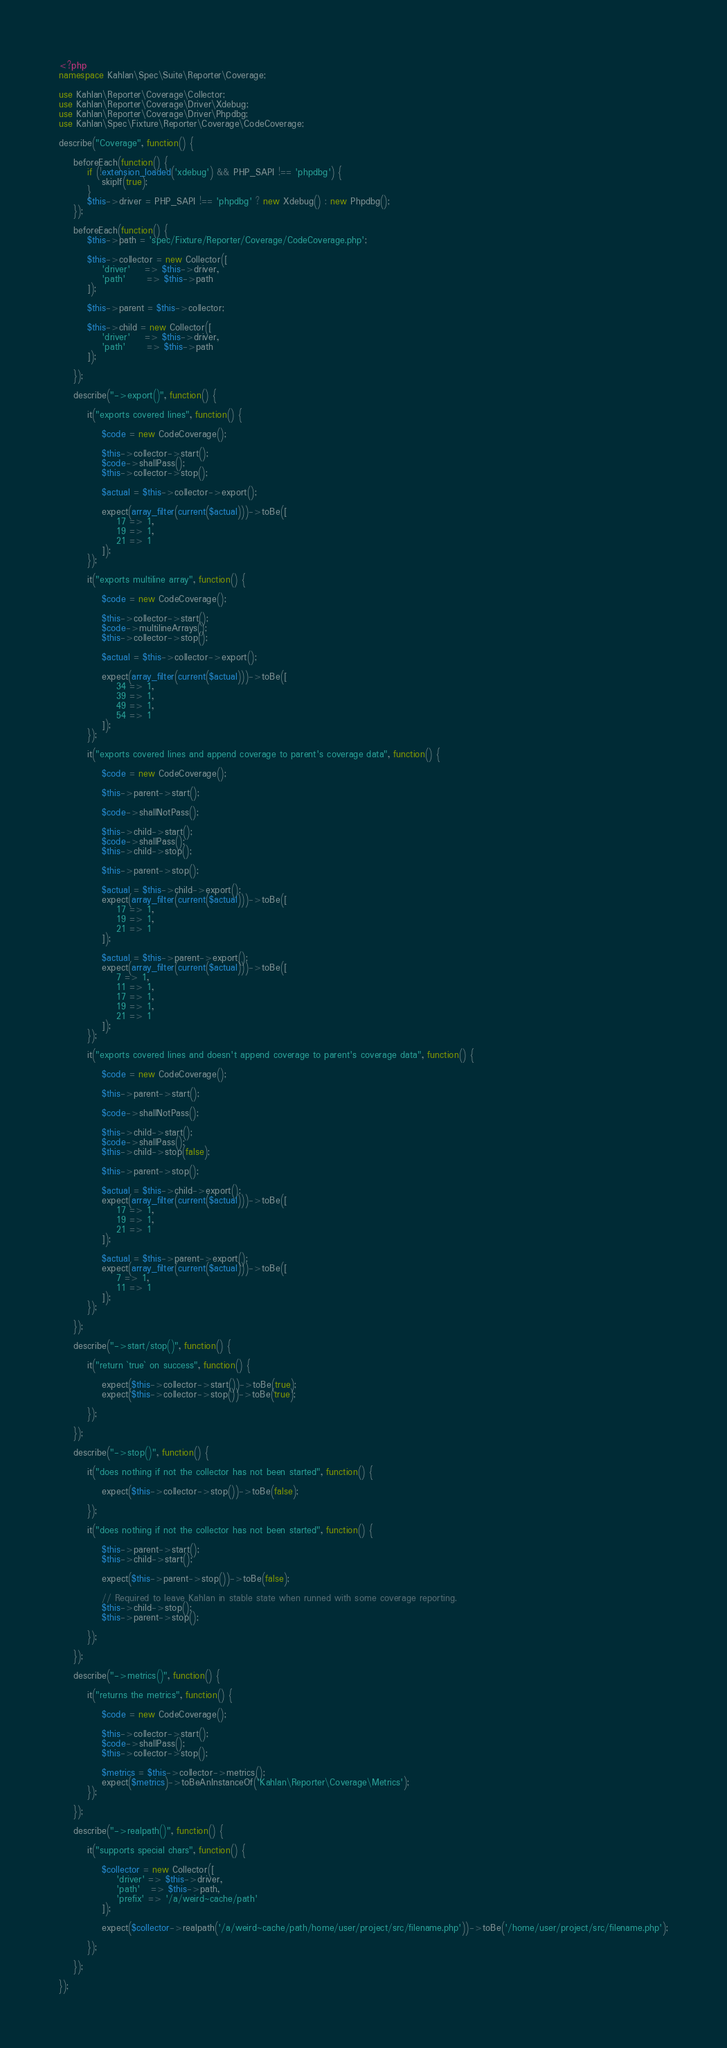Convert code to text. <code><loc_0><loc_0><loc_500><loc_500><_PHP_><?php
namespace Kahlan\Spec\Suite\Reporter\Coverage;

use Kahlan\Reporter\Coverage\Collector;
use Kahlan\Reporter\Coverage\Driver\Xdebug;
use Kahlan\Reporter\Coverage\Driver\Phpdbg;
use Kahlan\Spec\Fixture\Reporter\Coverage\CodeCoverage;

describe("Coverage", function() {

    beforeEach(function() {
        if (!extension_loaded('xdebug') && PHP_SAPI !== 'phpdbg') {
            skipIf(true);
        }
        $this->driver = PHP_SAPI !== 'phpdbg' ? new Xdebug() : new Phpdbg();
    });

    beforeEach(function() {
        $this->path = 'spec/Fixture/Reporter/Coverage/CodeCoverage.php';

        $this->collector = new Collector([
            'driver'    => $this->driver,
            'path'      => $this->path
        ]);

        $this->parent = $this->collector;

        $this->child = new Collector([
            'driver'    => $this->driver,
            'path'      => $this->path
        ]);

    });

    describe("->export()", function() {

        it("exports covered lines", function() {

            $code = new CodeCoverage();

            $this->collector->start();
            $code->shallPass();
            $this->collector->stop();

            $actual = $this->collector->export();

            expect(array_filter(current($actual)))->toBe([
                17 => 1,
                19 => 1,
                21 => 1
            ]);
        });

        it("exports multiline array", function() {

            $code = new CodeCoverage();

            $this->collector->start();
            $code->multilineArrays();
            $this->collector->stop();

            $actual = $this->collector->export();

            expect(array_filter(current($actual)))->toBe([
                34 => 1,
                39 => 1,
                49 => 1,
                54 => 1
            ]);
        });

        it("exports covered lines and append coverage to parent's coverage data", function() {

            $code = new CodeCoverage();

            $this->parent->start();

            $code->shallNotPass();

            $this->child->start();
            $code->shallPass();
            $this->child->stop();

            $this->parent->stop();

            $actual = $this->child->export();
            expect(array_filter(current($actual)))->toBe([
                17 => 1,
                19 => 1,
                21 => 1
            ]);

            $actual = $this->parent->export();
            expect(array_filter(current($actual)))->toBe([
                7 => 1,
                11 => 1,
                17 => 1,
                19 => 1,
                21 => 1
            ]);
        });

        it("exports covered lines and doesn't append coverage to parent's coverage data", function() {

            $code = new CodeCoverage();

            $this->parent->start();

            $code->shallNotPass();

            $this->child->start();
            $code->shallPass();
            $this->child->stop(false);

            $this->parent->stop();

            $actual = $this->child->export();
            expect(array_filter(current($actual)))->toBe([
                17 => 1,
                19 => 1,
                21 => 1
            ]);

            $actual = $this->parent->export();
            expect(array_filter(current($actual)))->toBe([
                7 => 1,
                11 => 1
            ]);
        });

    });

    describe("->start/stop()", function() {

        it("return `true` on success", function() {

            expect($this->collector->start())->toBe(true);
            expect($this->collector->stop())->toBe(true);

        });

    });

    describe("->stop()", function() {

        it("does nothing if not the collector has not been started", function() {

            expect($this->collector->stop())->toBe(false);

        });

        it("does nothing if not the collector has not been started", function() {

            $this->parent->start();
            $this->child->start();

            expect($this->parent->stop())->toBe(false);

            // Required to leave Kahlan in stable state when runned with some coverage reporting.
            $this->child->stop();
            $this->parent->stop();

        });

    });

    describe("->metrics()", function() {

        it("returns the metrics", function() {

            $code = new CodeCoverage();

            $this->collector->start();
            $code->shallPass();
            $this->collector->stop();

            $metrics = $this->collector->metrics();
            expect($metrics)->toBeAnInstanceOf('Kahlan\Reporter\Coverage\Metrics');
        });

    });

    describe("->realpath()", function() {

        it("supports special chars", function() {

            $collector = new Collector([
                'driver' => $this->driver,
                'path'   => $this->path,
                'prefix' => '/a/weird~cache/path'
            ]);

            expect($collector->realpath('/a/weird~cache/path/home/user/project/src/filename.php'))->toBe('/home/user/project/src/filename.php');

        });

    });

});
</code> 